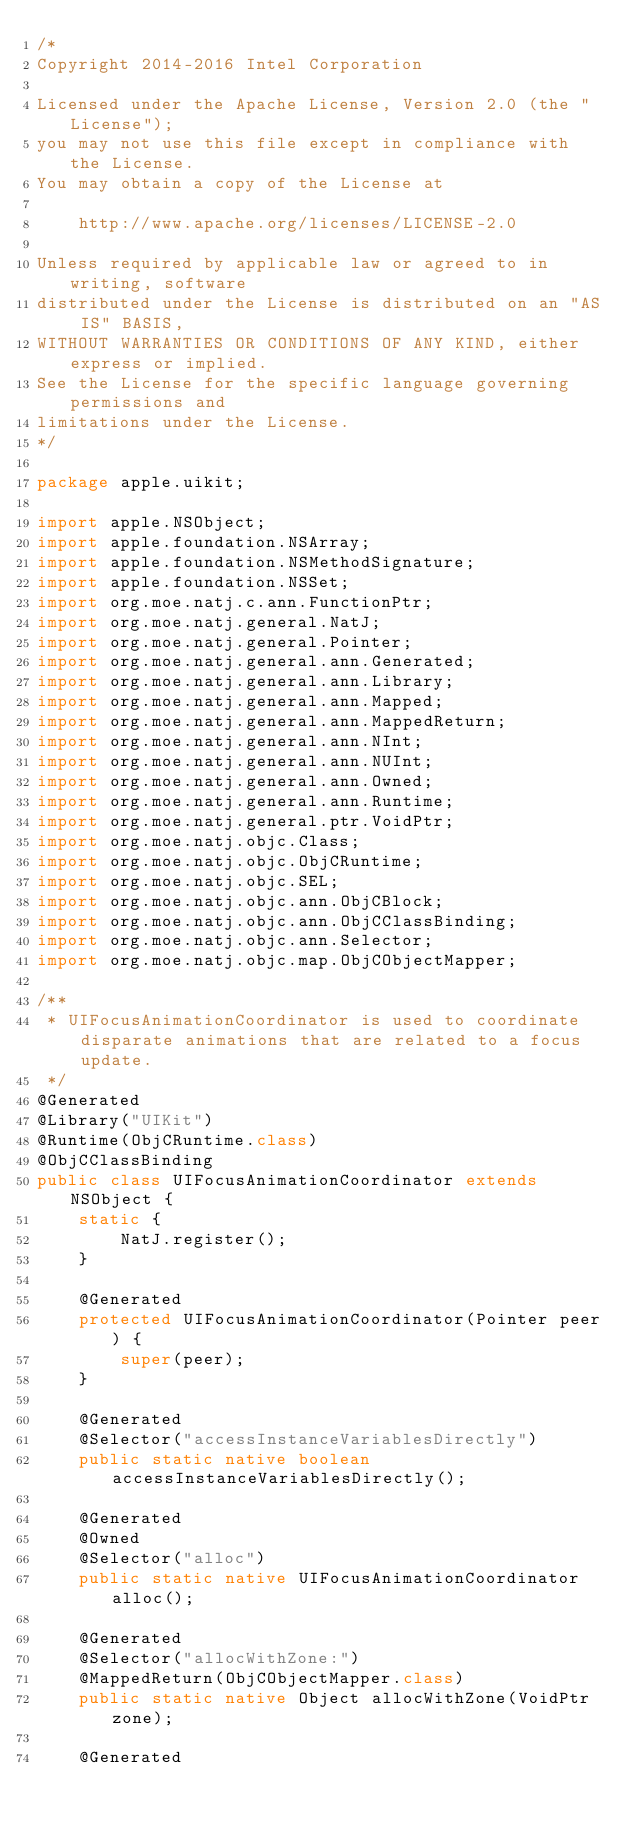<code> <loc_0><loc_0><loc_500><loc_500><_Java_>/*
Copyright 2014-2016 Intel Corporation

Licensed under the Apache License, Version 2.0 (the "License");
you may not use this file except in compliance with the License.
You may obtain a copy of the License at

    http://www.apache.org/licenses/LICENSE-2.0

Unless required by applicable law or agreed to in writing, software
distributed under the License is distributed on an "AS IS" BASIS,
WITHOUT WARRANTIES OR CONDITIONS OF ANY KIND, either express or implied.
See the License for the specific language governing permissions and
limitations under the License.
*/

package apple.uikit;

import apple.NSObject;
import apple.foundation.NSArray;
import apple.foundation.NSMethodSignature;
import apple.foundation.NSSet;
import org.moe.natj.c.ann.FunctionPtr;
import org.moe.natj.general.NatJ;
import org.moe.natj.general.Pointer;
import org.moe.natj.general.ann.Generated;
import org.moe.natj.general.ann.Library;
import org.moe.natj.general.ann.Mapped;
import org.moe.natj.general.ann.MappedReturn;
import org.moe.natj.general.ann.NInt;
import org.moe.natj.general.ann.NUInt;
import org.moe.natj.general.ann.Owned;
import org.moe.natj.general.ann.Runtime;
import org.moe.natj.general.ptr.VoidPtr;
import org.moe.natj.objc.Class;
import org.moe.natj.objc.ObjCRuntime;
import org.moe.natj.objc.SEL;
import org.moe.natj.objc.ann.ObjCBlock;
import org.moe.natj.objc.ann.ObjCClassBinding;
import org.moe.natj.objc.ann.Selector;
import org.moe.natj.objc.map.ObjCObjectMapper;

/**
 * UIFocusAnimationCoordinator is used to coordinate disparate animations that are related to a focus update.
 */
@Generated
@Library("UIKit")
@Runtime(ObjCRuntime.class)
@ObjCClassBinding
public class UIFocusAnimationCoordinator extends NSObject {
    static {
        NatJ.register();
    }

    @Generated
    protected UIFocusAnimationCoordinator(Pointer peer) {
        super(peer);
    }

    @Generated
    @Selector("accessInstanceVariablesDirectly")
    public static native boolean accessInstanceVariablesDirectly();

    @Generated
    @Owned
    @Selector("alloc")
    public static native UIFocusAnimationCoordinator alloc();

    @Generated
    @Selector("allocWithZone:")
    @MappedReturn(ObjCObjectMapper.class)
    public static native Object allocWithZone(VoidPtr zone);

    @Generated</code> 